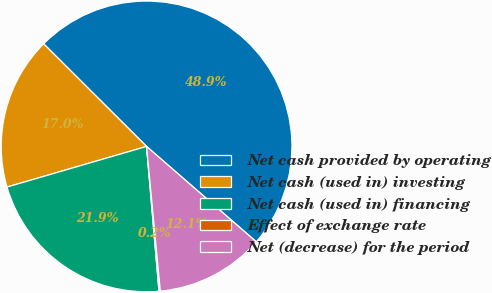Convert chart to OTSL. <chart><loc_0><loc_0><loc_500><loc_500><pie_chart><fcel>Net cash provided by operating<fcel>Net cash (used in) investing<fcel>Net cash (used in) financing<fcel>Effect of exchange rate<fcel>Net (decrease) for the period<nl><fcel>48.91%<fcel>16.98%<fcel>21.85%<fcel>0.15%<fcel>12.1%<nl></chart> 